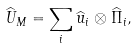Convert formula to latex. <formula><loc_0><loc_0><loc_500><loc_500>\widehat { U } _ { M } \/ = \sum _ { i } \widehat { u } _ { i } \otimes \widehat { \Pi } _ { i } ,</formula> 